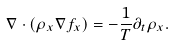<formula> <loc_0><loc_0><loc_500><loc_500>\nabla \cdot \left ( \rho _ { x } \nabla f _ { x } \right ) = - \frac { 1 } { T } \partial _ { t } \rho _ { x } .</formula> 